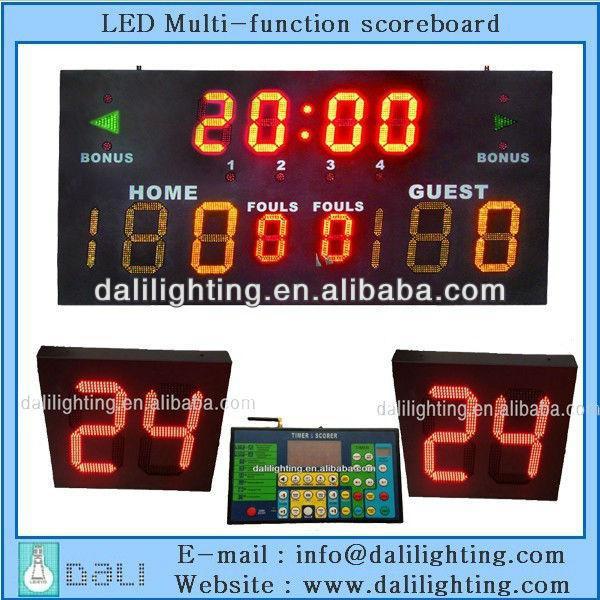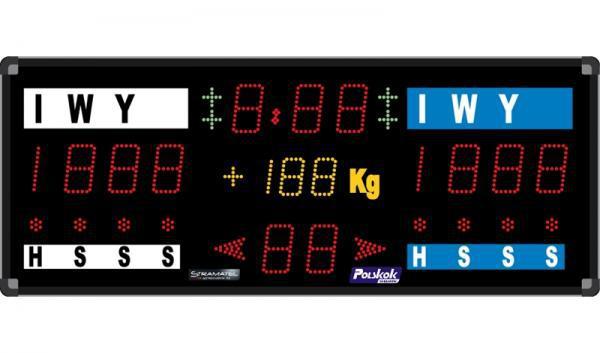The first image is the image on the left, the second image is the image on the right. For the images shown, is this caption "Each scoreboard includes blue and white sections, and one scoreboard has a blue top section and white on the bottom." true? Answer yes or no. No. The first image is the image on the left, the second image is the image on the right. Evaluate the accuracy of this statement regarding the images: "One of the interfaces contains a weight category.". Is it true? Answer yes or no. Yes. 